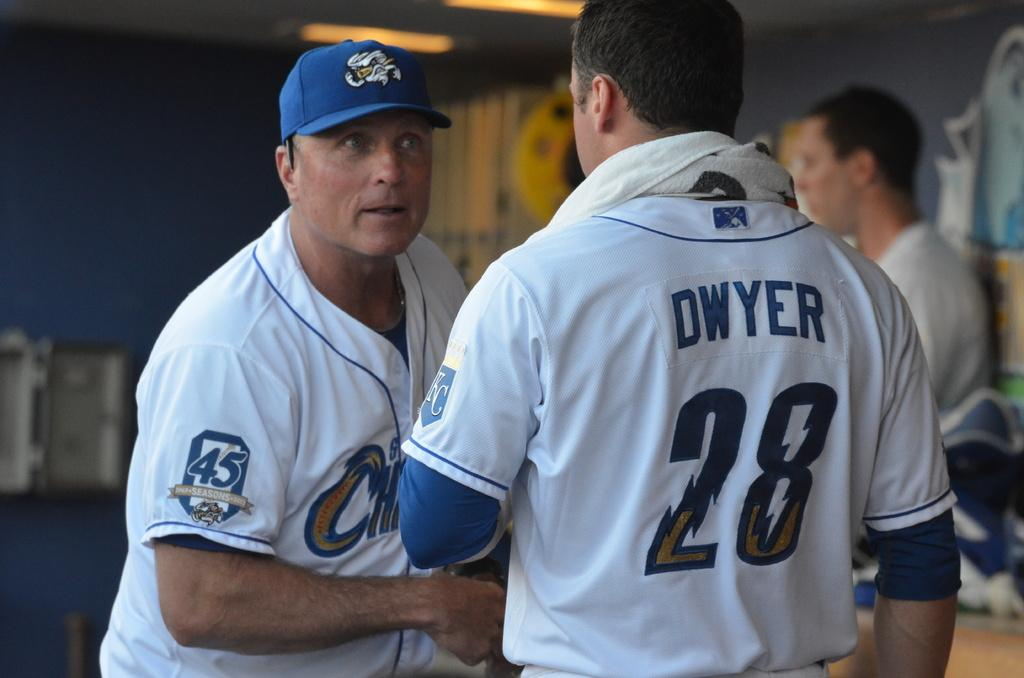<image>
Relay a brief, clear account of the picture shown. A man staring at another man as he wears a baseball uniform with the name Dwyer 28 on it. 